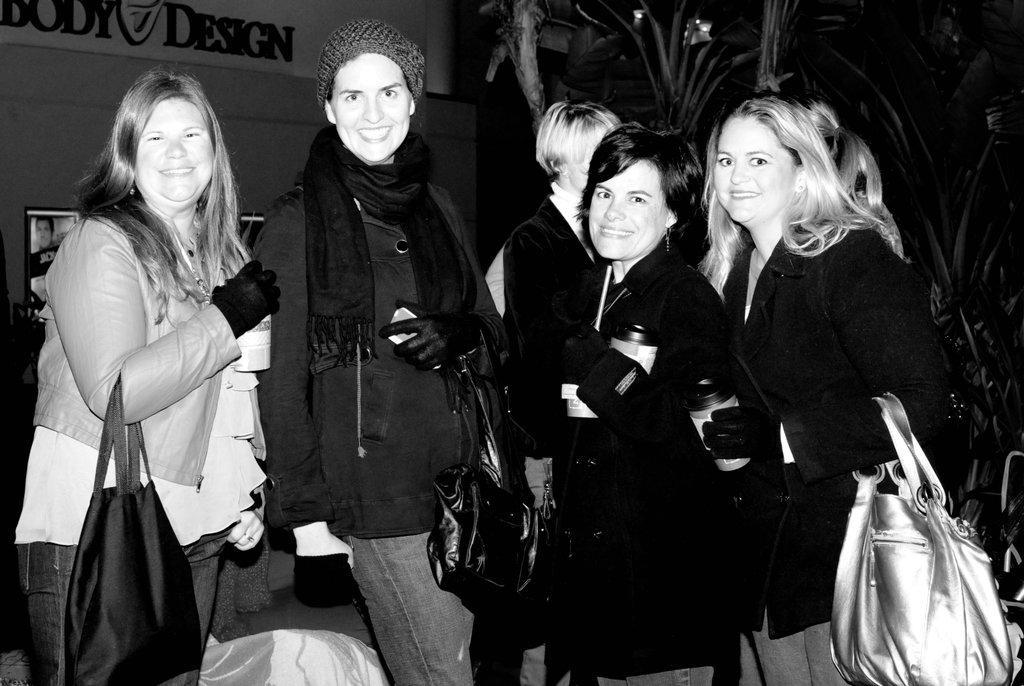Could you give a brief overview of what you see in this image? A group of women are posing to camera. 